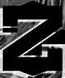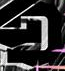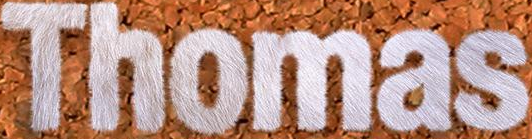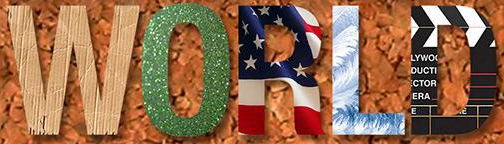What words can you see in these images in sequence, separated by a semicolon? Z; D; Thomas; WORLD 